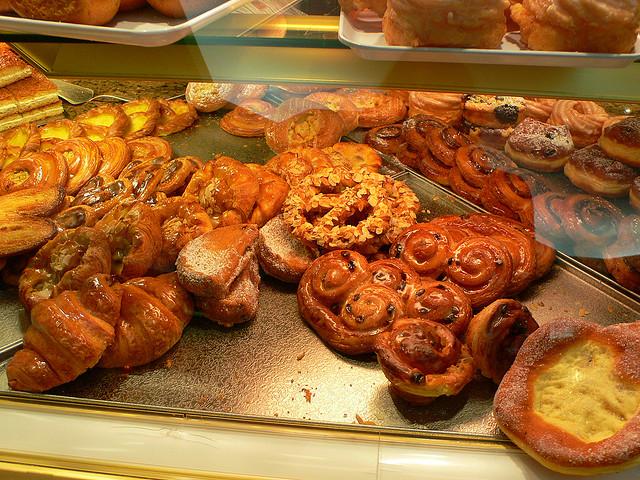Are there raisins in this photo?
Concise answer only. Yes. Is this pizza?
Quick response, please. No. What is being sold at this store?
Give a very brief answer. Pastries. 